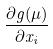<formula> <loc_0><loc_0><loc_500><loc_500>\frac { \partial g ( \mu ) } { \partial x _ { i } }</formula> 